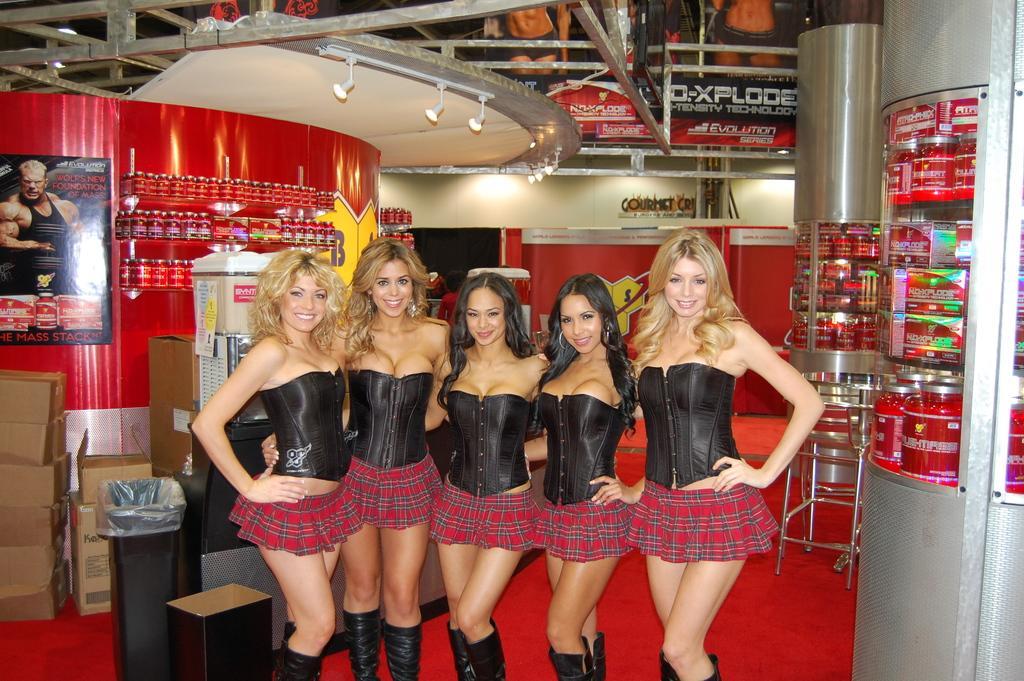Describe this image in one or two sentences. In the center of the image we can see ladies standing. In the background there are pillars and we can see boxes. There is bin and we can see a table. On the right there is a stand. We can see boards placed on the wall. 